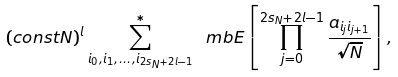<formula> <loc_0><loc_0><loc_500><loc_500>( c o n s t N ) ^ { l } \sum ^ { * } _ { i _ { 0 } , i _ { 1 } , \dots , i _ { 2 s _ { N } + 2 l - 1 } } \ m b E \left [ \prod _ { j = 0 } ^ { 2 s _ { N } + 2 l - 1 } \frac { a _ { i _ { j } i _ { j + 1 } } } { \sqrt { N } } \right ] ,</formula> 